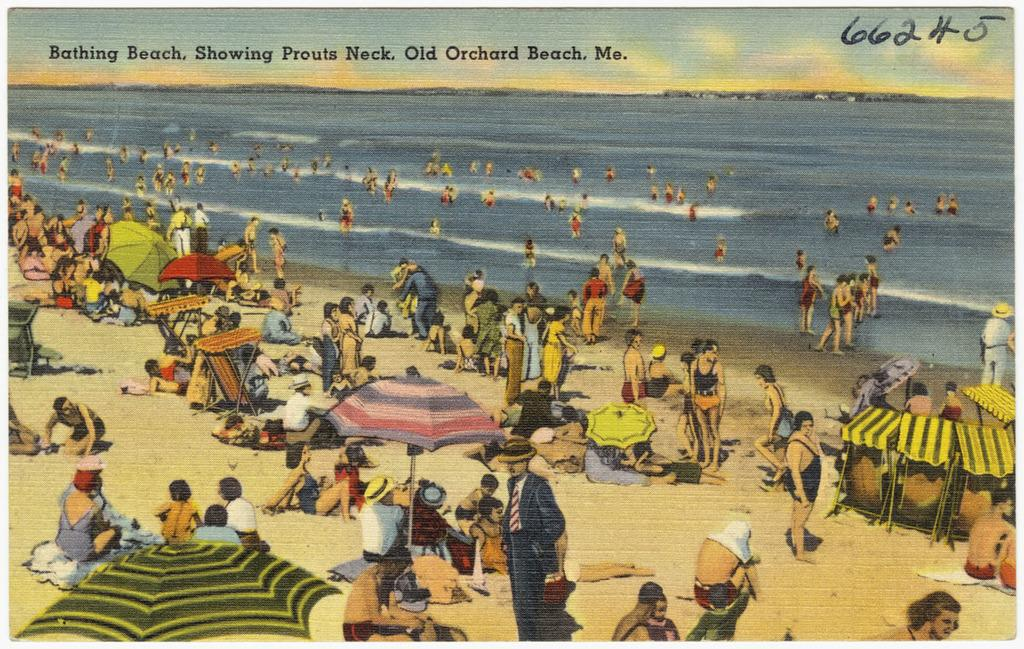<image>
Describe the image concisely. Postcard from a Bathing Beach in Old Orchard Beach in Maine. 